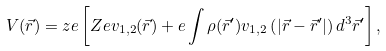Convert formula to latex. <formula><loc_0><loc_0><loc_500><loc_500>V ( \vec { r } ) = z e \left [ Z e v _ { 1 , 2 } ( \vec { r } ) + e \int \rho ( \vec { r } ^ { \prime } ) v _ { 1 , 2 } \left ( | \vec { r } - \vec { r } ^ { \prime } | \right ) d ^ { 3 } \vec { r } ^ { \prime } \right ] ,</formula> 